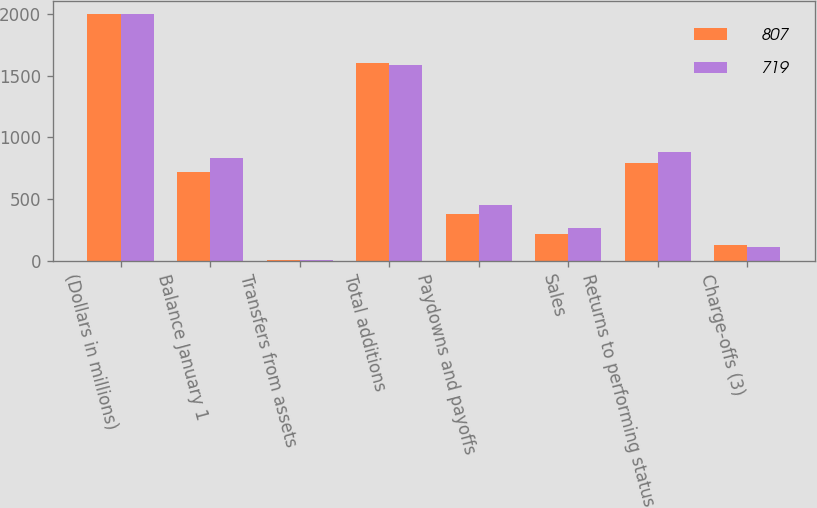Convert chart to OTSL. <chart><loc_0><loc_0><loc_500><loc_500><stacked_bar_chart><ecel><fcel>(Dollars in millions)<fcel>Balance January 1<fcel>Transfers from assets<fcel>Total additions<fcel>Paydowns and payoffs<fcel>Sales<fcel>Returns to performing status<fcel>Charge-offs (3)<nl><fcel>807<fcel>2004<fcel>719<fcel>1<fcel>1604<fcel>376<fcel>219<fcel>793<fcel>128<nl><fcel>719<fcel>2003<fcel>832<fcel>5<fcel>1588<fcel>447<fcel>265<fcel>878<fcel>111<nl></chart> 